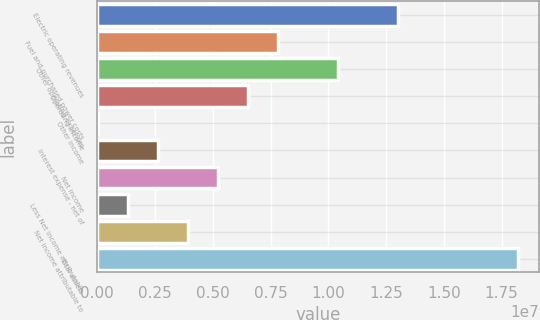Convert chart to OTSL. <chart><loc_0><loc_0><loc_500><loc_500><bar_chart><fcel>Electric operating revenues<fcel>Fuel and purchased power costs<fcel>Other operating expenses<fcel>Operating income<fcel>Other income<fcel>Interest expense - net of<fcel>Net income<fcel>Less Net income attributable<fcel>Net income attributable to<fcel>Total assets<nl><fcel>1.30111e+07<fcel>7.81662e+06<fcel>1.04138e+07<fcel>6.51802e+06<fcel>24974<fcel>2.62219e+06<fcel>5.21941e+06<fcel>1.32358e+06<fcel>3.9208e+06<fcel>1.82055e+07<nl></chart> 